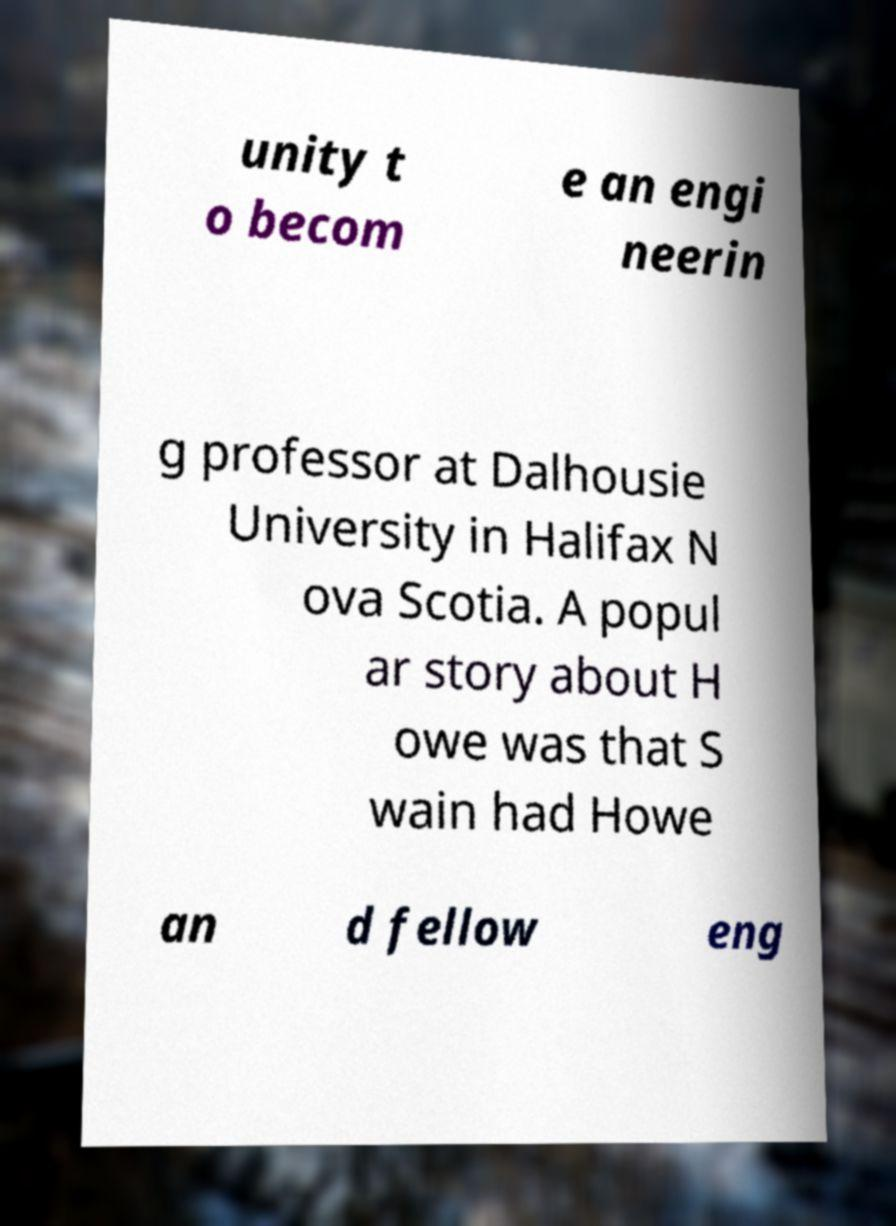There's text embedded in this image that I need extracted. Can you transcribe it verbatim? unity t o becom e an engi neerin g professor at Dalhousie University in Halifax N ova Scotia. A popul ar story about H owe was that S wain had Howe an d fellow eng 